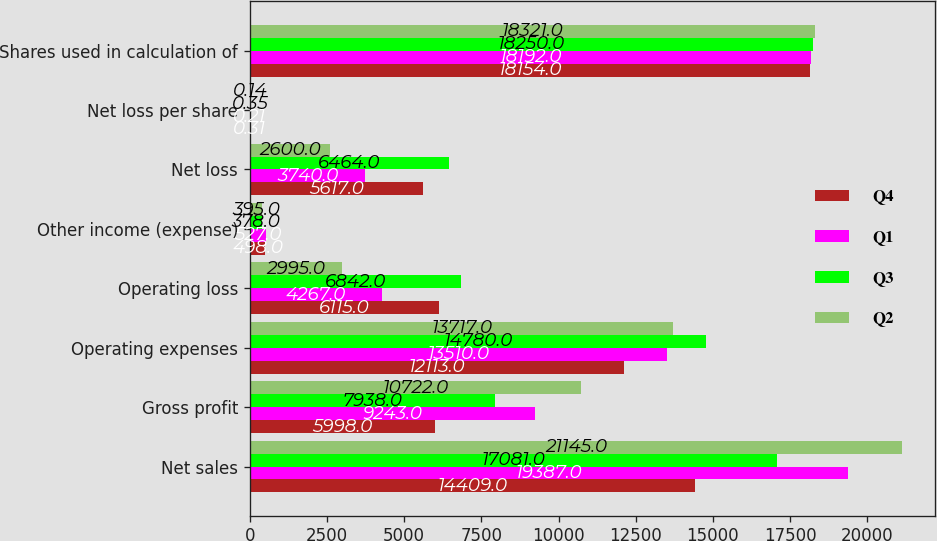Convert chart. <chart><loc_0><loc_0><loc_500><loc_500><stacked_bar_chart><ecel><fcel>Net sales<fcel>Gross profit<fcel>Operating expenses<fcel>Operating loss<fcel>Other income (expense)<fcel>Net loss<fcel>Net loss per share<fcel>Shares used in calculation of<nl><fcel>Q4<fcel>14409<fcel>5998<fcel>12113<fcel>6115<fcel>498<fcel>5617<fcel>0.31<fcel>18154<nl><fcel>Q1<fcel>19387<fcel>9243<fcel>13510<fcel>4267<fcel>527<fcel>3740<fcel>0.21<fcel>18192<nl><fcel>Q3<fcel>17081<fcel>7938<fcel>14780<fcel>6842<fcel>378<fcel>6464<fcel>0.35<fcel>18250<nl><fcel>Q2<fcel>21145<fcel>10722<fcel>13717<fcel>2995<fcel>395<fcel>2600<fcel>0.14<fcel>18321<nl></chart> 